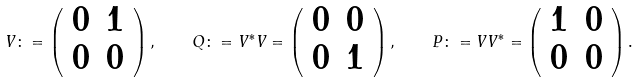<formula> <loc_0><loc_0><loc_500><loc_500>V \colon = \left ( \begin{array} { c c } 0 & 1 \\ 0 & 0 \\ \end{array} \right ) , \quad Q \colon = V ^ { * } V = \left ( \begin{array} { c c } 0 & 0 \\ 0 & 1 \\ \end{array} \right ) , \quad P \colon = V V ^ { * } = \left ( \begin{array} { c c } 1 & 0 \\ 0 & 0 \\ \end{array} \right ) .</formula> 